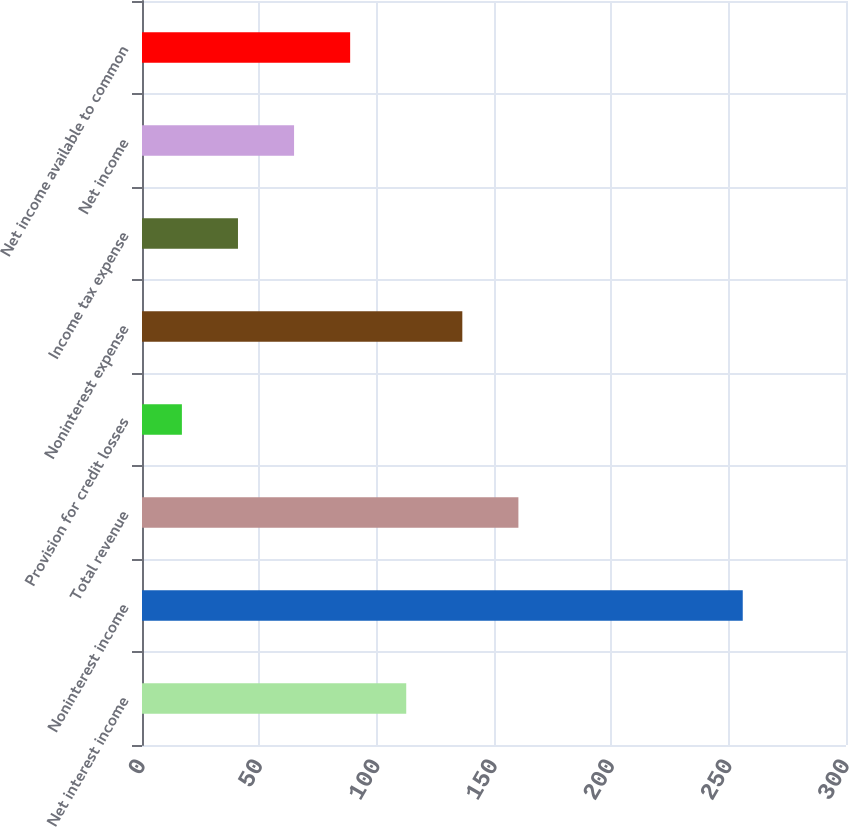Convert chart to OTSL. <chart><loc_0><loc_0><loc_500><loc_500><bar_chart><fcel>Net interest income<fcel>Noninterest income<fcel>Total revenue<fcel>Provision for credit losses<fcel>Noninterest expense<fcel>Income tax expense<fcel>Net income<fcel>Net income available to common<nl><fcel>112.6<fcel>256<fcel>160.4<fcel>17<fcel>136.5<fcel>40.9<fcel>64.8<fcel>88.7<nl></chart> 